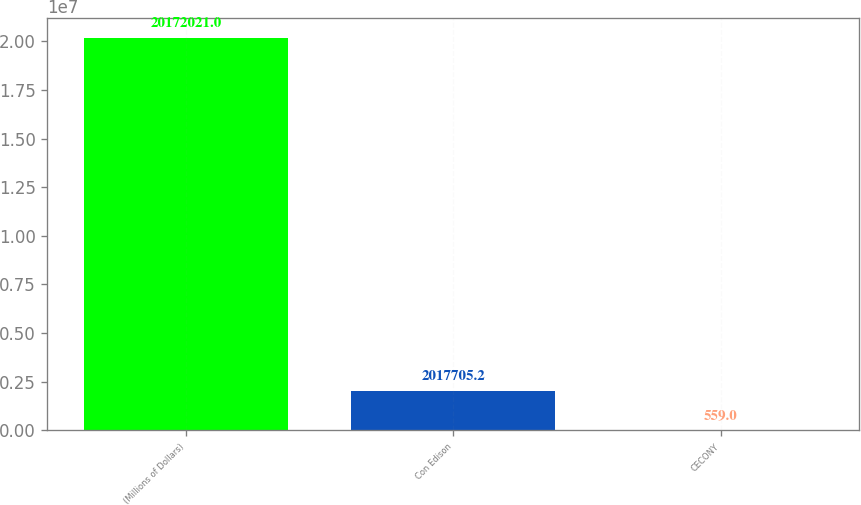<chart> <loc_0><loc_0><loc_500><loc_500><bar_chart><fcel>(Millions of Dollars)<fcel>Con Edison<fcel>CECONY<nl><fcel>2.0172e+07<fcel>2.01771e+06<fcel>559<nl></chart> 